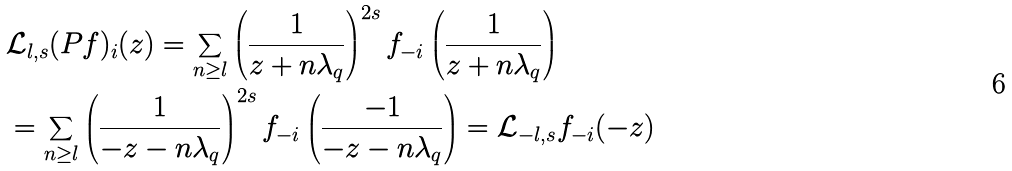<formula> <loc_0><loc_0><loc_500><loc_500>& \mathcal { L } _ { l , s } ( P f ) _ { i } ( z ) = \sum _ { n \geq l } \left ( \frac { 1 } { z + n \lambda _ { q } } \right ) ^ { 2 s } f _ { - i } \left ( \frac { 1 } { z + n \lambda _ { q } } \right ) \\ & = \sum _ { n \geq l } \left ( \frac { 1 } { - z - n \lambda _ { q } } \right ) ^ { 2 s } f _ { - i } \left ( \frac { - 1 } { - z - n \lambda _ { q } } \right ) = \mathcal { L } _ { - l , s } f _ { - i } ( - z )</formula> 